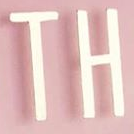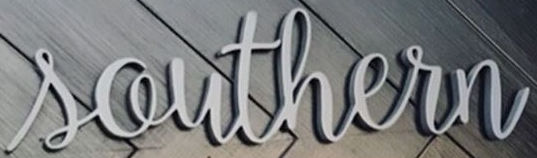Identify the words shown in these images in order, separated by a semicolon. TH; Southern 